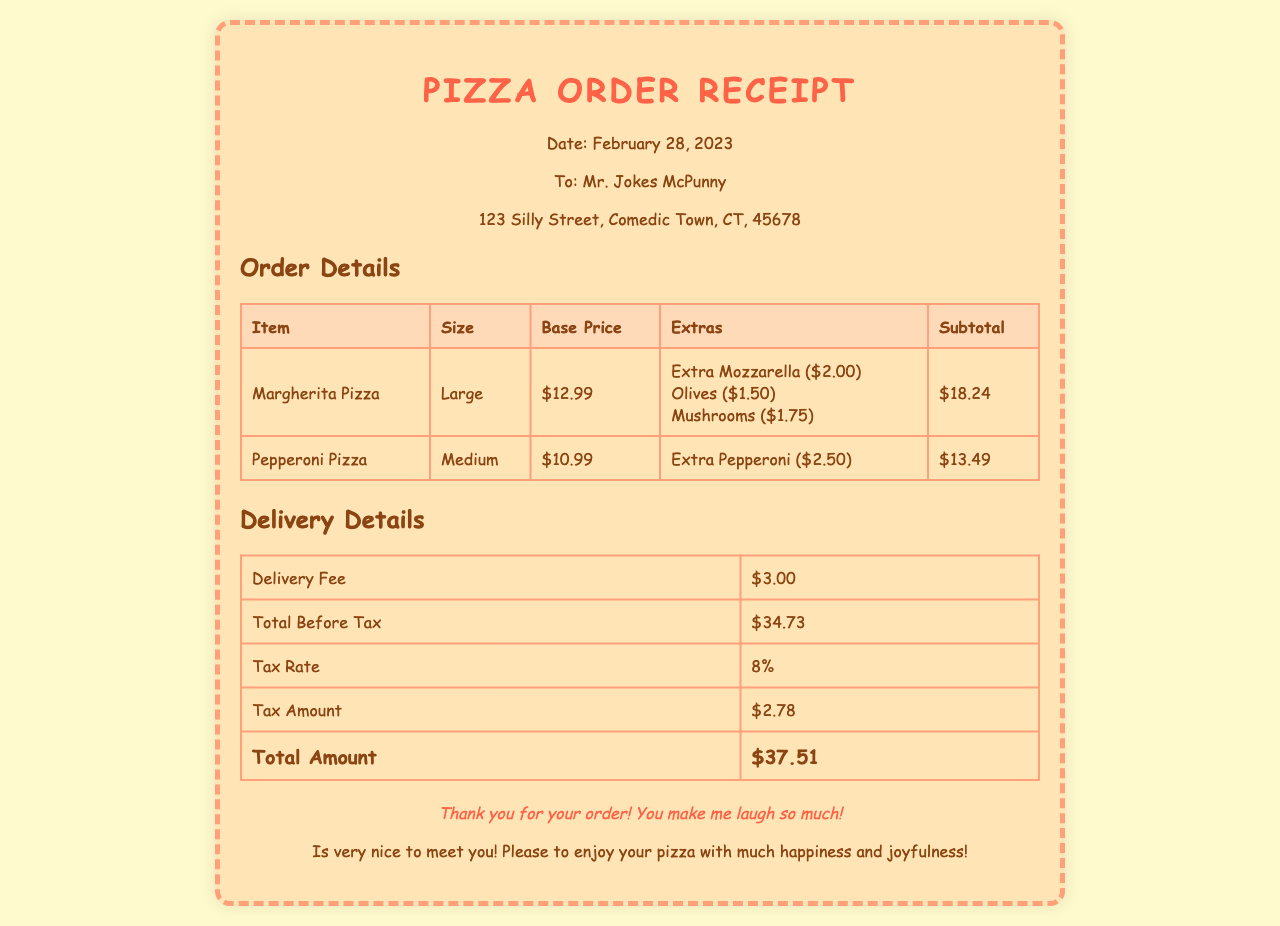What date is on the receipt? The date listed on the receipt indicates when the order was made, which is February 28, 2023.
Answer: February 28, 2023 Who is the receipt addressed to? The receipt shows the recipient's name and address, which is Mr. Jokes McPunny.
Answer: Mr. Jokes McPunny What is the subtotal for the Margherita Pizza? The subtotal for the Margherita Pizza is specifically listed in the order details section of the receipt.
Answer: $18.24 What extra topping costs $2.00? The receipt includes a list of extra toppings and their prices, indicating which topping costs $2.00.
Answer: Extra Mozzarella What is the tax rate applied to the order? The tax rate for the order is mentioned in the delivery details section of the receipt.
Answer: 8% What is the total amount due? The total amount due is summarized at the bottom of the delivery details section on the receipt.
Answer: $37.51 How much is the delivery fee? The delivery fee is specified in the delivery details section, which provides a clear value.
Answer: $3.00 What types of pizzas were ordered? The receipt details the specific varieties of pizzas that were part of the order, which is essential to understand the order.
Answer: Margherita Pizza, Pepperoni Pizza 